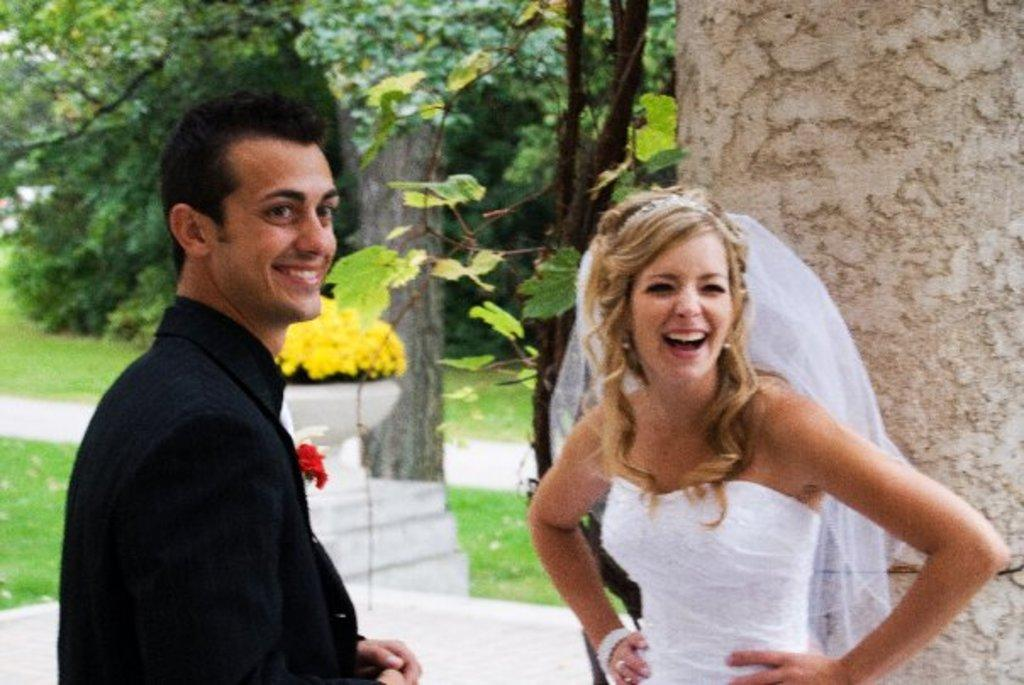How many people are present in the image? There are two people in the image, a lady and a guy. What are the lady and the guy doing in the image? Both the lady and the guy are standing. What type of natural elements can be seen in the image? There are trees, plants, and flowers associated with the trees and plants in the image. What type of waves can be heard in the image? There are no waves present in the image, as it is a still photograph. How does the acoustics of the lady and guy's conversation affect the image? The image is a still photograph, so there is no sound or conversation to be affected by acoustics. What scientific theory is being demonstrated in the image? There is no scientific theory being demonstrated in the image; it is a simple scene featuring a lady, a guy, and natural elements. 